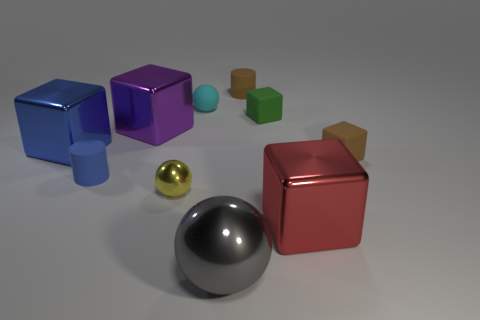How many things are shiny objects to the right of the tiny matte sphere or small red metal objects?
Give a very brief answer. 2. There is a red metallic thing that is the same size as the blue metallic block; what is its shape?
Offer a terse response. Cube. Is the size of the rubber cube to the right of the large red metal block the same as the brown object behind the blue metallic thing?
Provide a short and direct response. Yes. There is another small cube that is the same material as the green cube; what color is it?
Your answer should be compact. Brown. Do the thing on the left side of the tiny blue matte cylinder and the ball behind the small blue rubber cylinder have the same material?
Provide a succinct answer. No. Are there any cyan rubber balls that have the same size as the blue rubber object?
Your response must be concise. Yes. There is a brown thing behind the small brown matte thing that is in front of the small brown matte cylinder; how big is it?
Make the answer very short. Small. How many other tiny rubber balls are the same color as the tiny rubber ball?
Provide a short and direct response. 0. There is a tiny brown thing on the left side of the rubber block behind the big purple metallic object; what is its shape?
Offer a terse response. Cylinder. What number of large purple cubes have the same material as the gray thing?
Give a very brief answer. 1. 